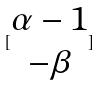Convert formula to latex. <formula><loc_0><loc_0><loc_500><loc_500>[ \begin{matrix} \alpha - 1 \\ - \beta \end{matrix} ]</formula> 